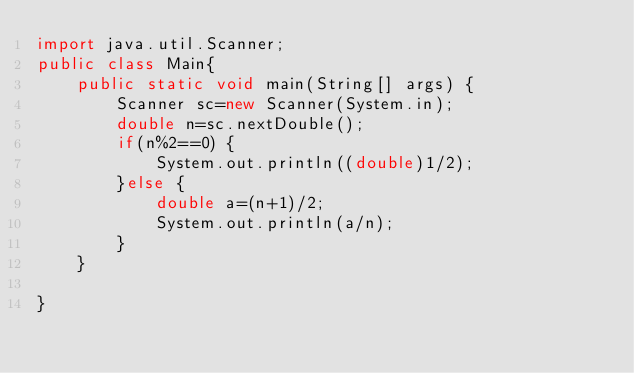<code> <loc_0><loc_0><loc_500><loc_500><_Java_>import java.util.Scanner;
public class Main{
	public static void main(String[] args) {
		Scanner sc=new Scanner(System.in);
		double n=sc.nextDouble();
		if(n%2==0) {
			System.out.println((double)1/2);
		}else {
			double a=(n+1)/2;
			System.out.println(a/n);
		}
	}

}
</code> 